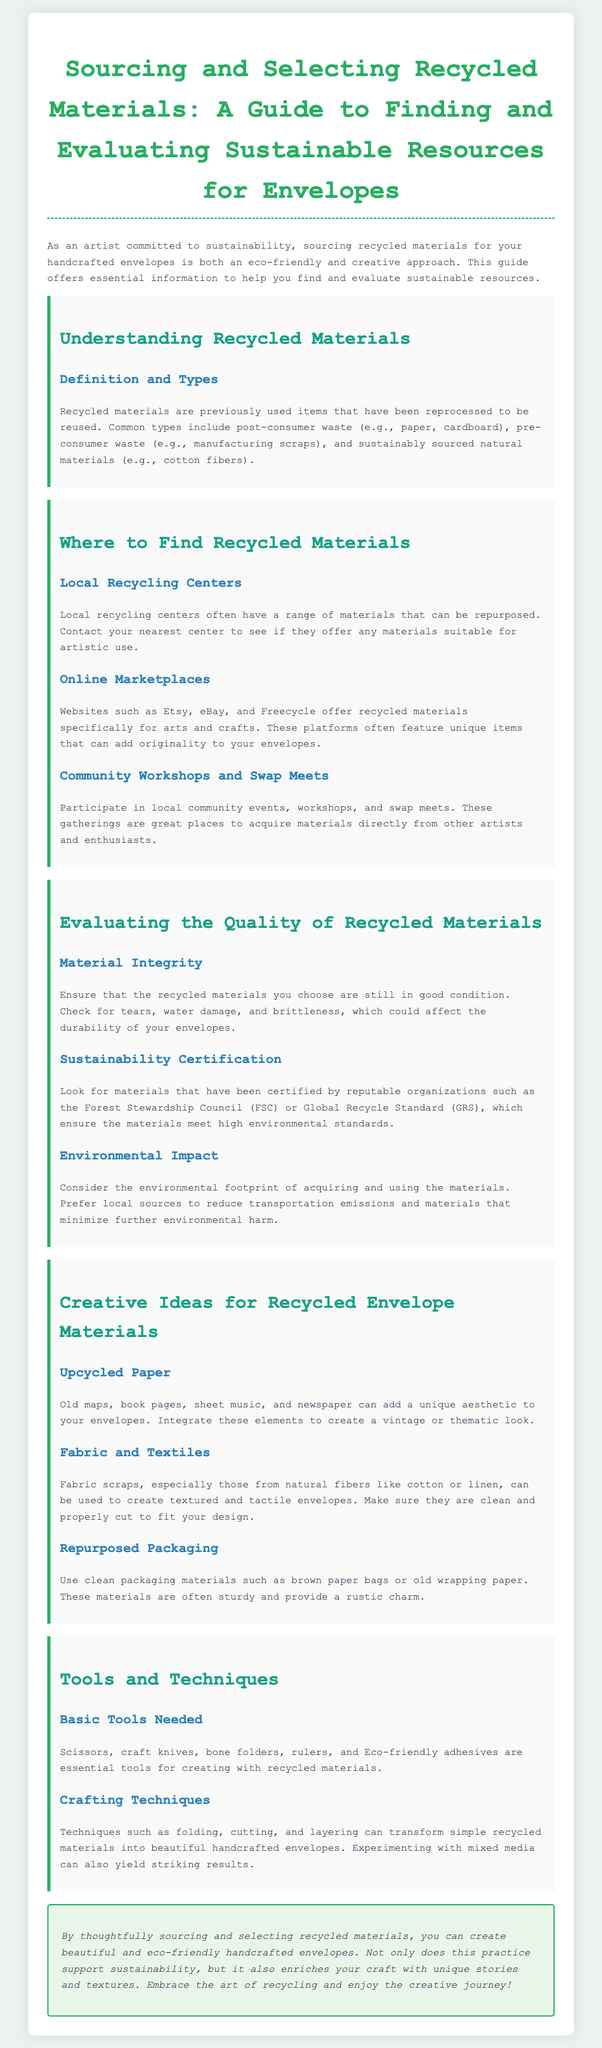What are common types of recycled materials? The document lists post-consumer waste, pre-consumer waste, and sustainably sourced natural materials as common types of recycled materials.
Answer: post-consumer waste, pre-consumer waste, sustainably sourced natural materials Where can you find recycled materials? The document specifies local recycling centers, online marketplaces, and community workshops and swap meets as places to find recycled materials.
Answer: local recycling centers, online marketplaces, community workshops and swap meets What should you check for in material integrity? The document suggests checking for tears, water damage, and brittleness when evaluating the quality of recycled materials.
Answer: tears, water damage, brittleness Which certification should you look for in sustainable materials? The document recommends looking for certifications from the Forest Stewardship Council or the Global Recycle Standard.
Answer: Forest Stewardship Council, Global Recycle Standard What can upcycled paper include? The document lists old maps, book pages, sheet music, and newspaper as examples of upcycled paper.
Answer: old maps, book pages, sheet music, newspaper What tools are essential for creating with recycled materials? The document states that scissors, craft knives, bone folders, rulers, and Eco-friendly adhesives are essential tools.
Answer: scissors, craft knives, bone folders, rulers, Eco-friendly adhesives What crafting technique can transform recycled materials? The document mentions techniques such as folding, cutting, and layering as ways to transform recycled materials.
Answer: folding, cutting, layering What is the primary focus of the guide? The document emphasizes thoughtful sourcing and selecting of recycled materials for eco-friendly handcrafted envelopes.
Answer: sourcing and selecting recycled materials 